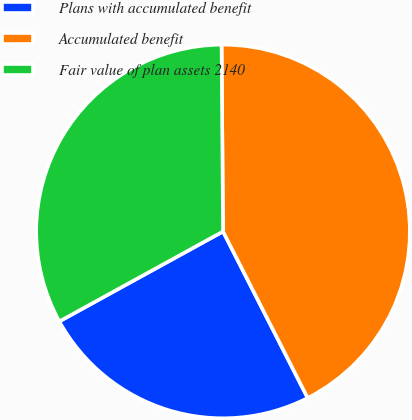Convert chart to OTSL. <chart><loc_0><loc_0><loc_500><loc_500><pie_chart><fcel>Plans with accumulated benefit<fcel>Accumulated benefit<fcel>Fair value of plan assets 2140<nl><fcel>24.49%<fcel>42.64%<fcel>32.87%<nl></chart> 